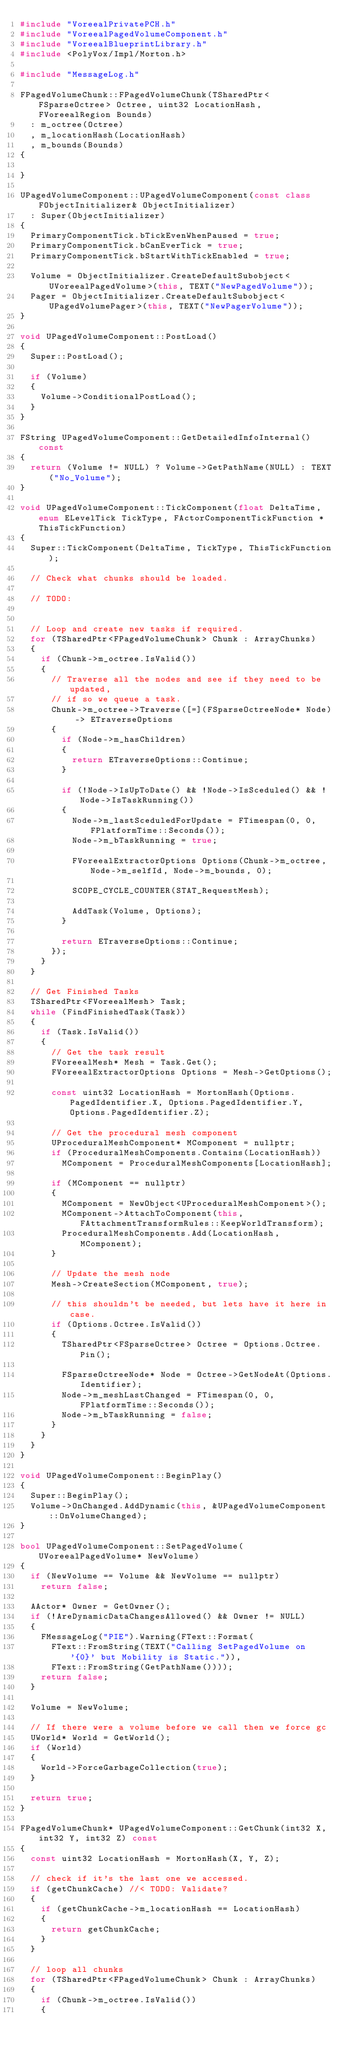<code> <loc_0><loc_0><loc_500><loc_500><_C++_>#include "VoreealPrivatePCH.h"
#include "VoreealPagedVolumeComponent.h"
#include "VoreealBlueprintLibrary.h"
#include <PolyVox/Impl/Morton.h>

#include "MessageLog.h"

FPagedVolumeChunk::FPagedVolumeChunk(TSharedPtr<FSparseOctree> Octree, uint32 LocationHash, FVoreealRegion Bounds)
	: m_octree(Octree)
	, m_locationHash(LocationHash)
	, m_bounds(Bounds)
{

}

UPagedVolumeComponent::UPagedVolumeComponent(const class FObjectInitializer& ObjectInitializer)
	: Super(ObjectInitializer)
{
	PrimaryComponentTick.bTickEvenWhenPaused = true;
	PrimaryComponentTick.bCanEverTick = true;
	PrimaryComponentTick.bStartWithTickEnabled = true;

	Volume = ObjectInitializer.CreateDefaultSubobject<UVoreealPagedVolume>(this, TEXT("NewPagedVolume"));
	Pager = ObjectInitializer.CreateDefaultSubobject<UPagedVolumePager>(this, TEXT("NewPagerVolume"));
}

void UPagedVolumeComponent::PostLoad()
{
	Super::PostLoad();

	if (Volume)
	{
		Volume->ConditionalPostLoad();
	}
}

FString UPagedVolumeComponent::GetDetailedInfoInternal() const
{
	return (Volume != NULL) ? Volume->GetPathName(NULL) : TEXT("No_Volume");
}

void UPagedVolumeComponent::TickComponent(float DeltaTime, enum ELevelTick TickType, FActorComponentTickFunction *ThisTickFunction)
{
	Super::TickComponent(DeltaTime, TickType, ThisTickFunction);

	// Check what chunks should be loaded.

	// TODO: 


	// Loop and create new tasks if required.
	for (TSharedPtr<FPagedVolumeChunk> Chunk : ArrayChunks)
	{
		if (Chunk->m_octree.IsValid())
		{
			// Traverse all the nodes and see if they need to be updated,
			// if so we queue a task.
			Chunk->m_octree->Traverse([=](FSparseOctreeNode* Node) -> ETraverseOptions
			{
				if (Node->m_hasChildren)
				{
					return ETraverseOptions::Continue;
				}

				if (!Node->IsUpToDate() && !Node->IsSceduled() && !Node->IsTaskRunning())
				{
					Node->m_lastSceduledForUpdate = FTimespan(0, 0, FPlatformTime::Seconds());
					Node->m_bTaskRunning = true;

					FVoreealExtractorOptions Options(Chunk->m_octree, Node->m_selfId, Node->m_bounds, 0);

					SCOPE_CYCLE_COUNTER(STAT_RequestMesh);

					AddTask(Volume, Options);
				}

				return ETraverseOptions::Continue;
			});
		}
	}

	// Get Finished Tasks
	TSharedPtr<FVoreealMesh> Task;
	while (FindFinishedTask(Task))
	{
		if (Task.IsValid())
		{
			// Get the task result
			FVoreealMesh* Mesh = Task.Get();
			FVoreealExtractorOptions Options = Mesh->GetOptions();

			const uint32 LocationHash = MortonHash(Options.PagedIdentifier.X, Options.PagedIdentifier.Y, Options.PagedIdentifier.Z);

			// Get the procedural mesh component 
			UProceduralMeshComponent* MComponent = nullptr;
			if (ProceduralMeshComponents.Contains(LocationHash))
				MComponent = ProceduralMeshComponents[LocationHash];

			if (MComponent == nullptr)
			{
				MComponent = NewObject<UProceduralMeshComponent>();
				MComponent->AttachToComponent(this, FAttachmentTransformRules::KeepWorldTransform);
				ProceduralMeshComponents.Add(LocationHash, MComponent);
			}

			// Update the mesh node
			Mesh->CreateSection(MComponent, true);

			// this shouldn't be needed, but lets have it here in case.
			if (Options.Octree.IsValid())
			{
				TSharedPtr<FSparseOctree> Octree = Options.Octree.Pin();
				
				FSparseOctreeNode* Node = Octree->GetNodeAt(Options.Identifier);
				Node->m_meshLastChanged = FTimespan(0, 0, FPlatformTime::Seconds());
				Node->m_bTaskRunning = false;
			}
		}
	}
}

void UPagedVolumeComponent::BeginPlay()
{
	Super::BeginPlay();
	Volume->OnChanged.AddDynamic(this, &UPagedVolumeComponent::OnVolumeChanged);
}

bool UPagedVolumeComponent::SetPagedVolume(UVoreealPagedVolume* NewVolume)
{
	if (NewVolume == Volume && NewVolume == nullptr)
		return false;

	AActor* Owner = GetOwner();
	if (!AreDynamicDataChangesAllowed() && Owner != NULL)
	{
		FMessageLog("PIE").Warning(FText::Format(
			FText::FromString(TEXT("Calling SetPagedVolume on '{0}' but Mobility is Static.")),
			FText::FromString(GetPathName())));
		return false;
	}

	Volume = NewVolume;

	// If there were a volume before we call then we force gc
	UWorld* World = GetWorld();
	if (World)
	{
		World->ForceGarbageCollection(true);
	}

	return true;
}

FPagedVolumeChunk* UPagedVolumeComponent::GetChunk(int32 X, int32 Y, int32 Z) const
{
	const uint32 LocationHash = MortonHash(X, Y, Z);

	// check if it's the last one we accessed. 
	if (getChunkCache) //< TODO: Validate?
	{
		if (getChunkCache->m_locationHash == LocationHash)
		{
			return getChunkCache;
		}
	}

	// loop all chunks
	for (TSharedPtr<FPagedVolumeChunk> Chunk : ArrayChunks)
	{
		if (Chunk->m_octree.IsValid())
		{</code> 